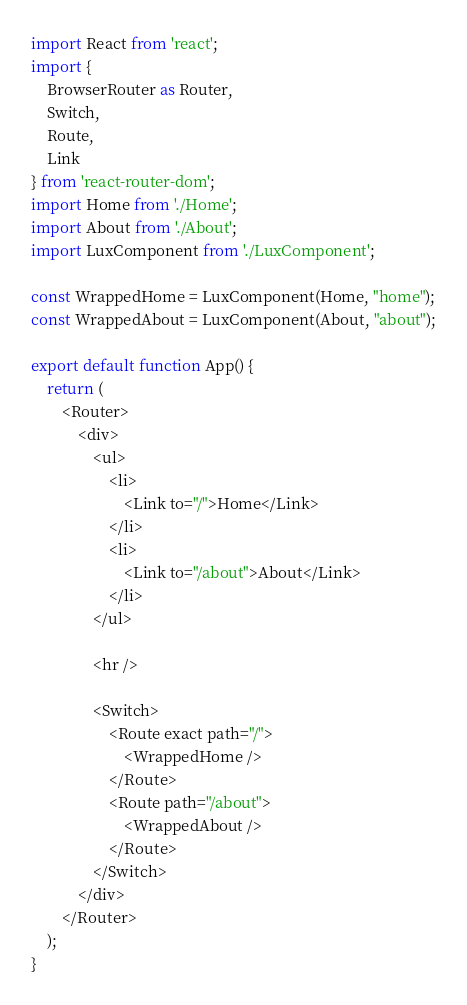<code> <loc_0><loc_0><loc_500><loc_500><_JavaScript_>import React from 'react';
import {
    BrowserRouter as Router,
    Switch,
    Route,
    Link
} from 'react-router-dom';
import Home from './Home';
import About from './About';
import LuxComponent from './LuxComponent';

const WrappedHome = LuxComponent(Home, "home");
const WrappedAbout = LuxComponent(About, "about");

export default function App() {
    return (
        <Router>
            <div>
                <ul>
                    <li>
                        <Link to="/">Home</Link>
                    </li>
                    <li>
                        <Link to="/about">About</Link>
                    </li>
                </ul>

                <hr />

                <Switch>
                    <Route exact path="/">
                        <WrappedHome />
                    </Route>
                    <Route path="/about">
                        <WrappedAbout />
                    </Route>
                </Switch>
            </div>
        </Router>
    );
}
</code> 